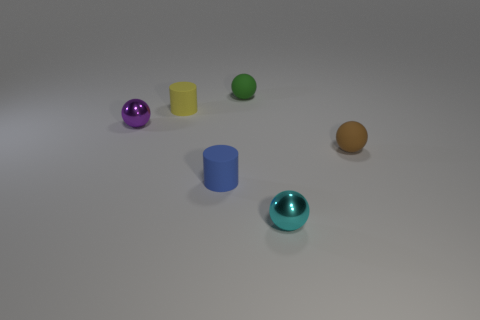Subtract 1 spheres. How many spheres are left? 3 Add 4 red objects. How many objects exist? 10 Subtract all cylinders. How many objects are left? 4 Add 4 tiny purple things. How many tiny purple things are left? 5 Add 5 tiny purple metallic cylinders. How many tiny purple metallic cylinders exist? 5 Subtract 0 gray cylinders. How many objects are left? 6 Subtract all yellow cylinders. Subtract all metallic balls. How many objects are left? 3 